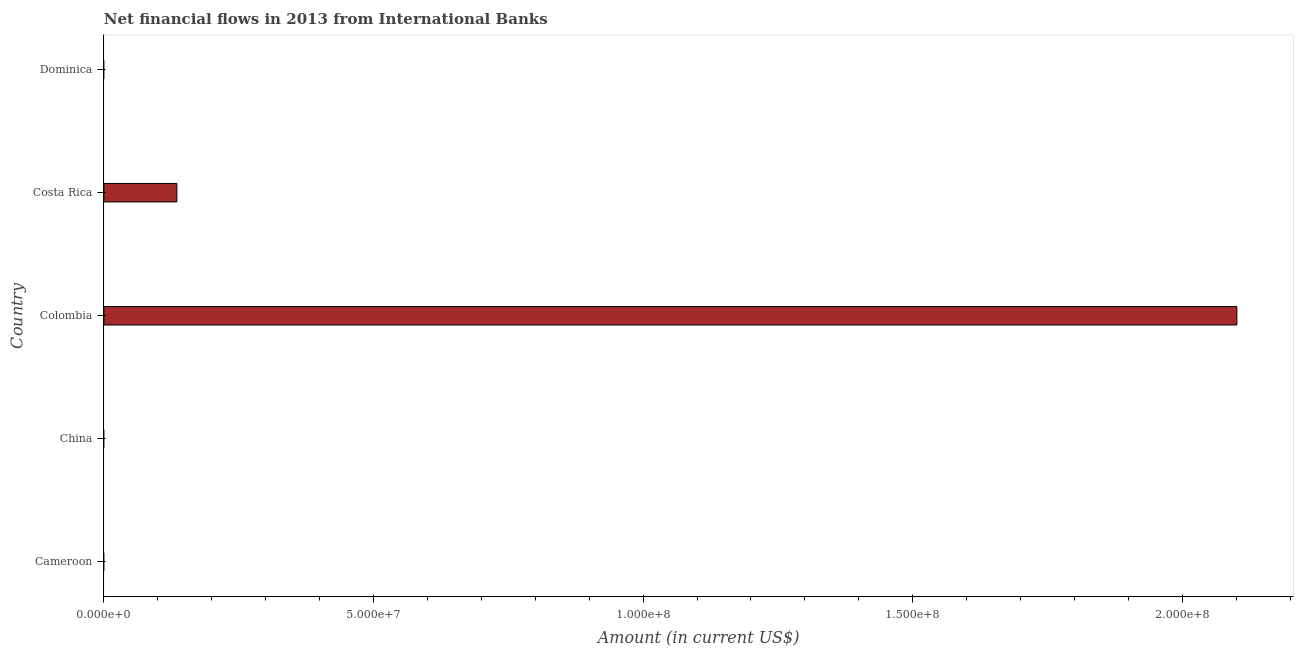Does the graph contain any zero values?
Provide a succinct answer. Yes. What is the title of the graph?
Provide a succinct answer. Net financial flows in 2013 from International Banks. What is the label or title of the X-axis?
Provide a succinct answer. Amount (in current US$). What is the label or title of the Y-axis?
Your response must be concise. Country. Across all countries, what is the maximum net financial flows from ibrd?
Provide a succinct answer. 2.10e+08. What is the sum of the net financial flows from ibrd?
Offer a very short reply. 2.24e+08. What is the difference between the net financial flows from ibrd in Colombia and Costa Rica?
Ensure brevity in your answer.  1.97e+08. What is the average net financial flows from ibrd per country?
Ensure brevity in your answer.  4.47e+07. What is the ratio of the net financial flows from ibrd in Colombia to that in Costa Rica?
Ensure brevity in your answer.  15.52. What is the difference between the highest and the lowest net financial flows from ibrd?
Keep it short and to the point. 2.10e+08. In how many countries, is the net financial flows from ibrd greater than the average net financial flows from ibrd taken over all countries?
Provide a short and direct response. 1. What is the difference between two consecutive major ticks on the X-axis?
Keep it short and to the point. 5.00e+07. Are the values on the major ticks of X-axis written in scientific E-notation?
Your answer should be very brief. Yes. What is the Amount (in current US$) of Colombia?
Give a very brief answer. 2.10e+08. What is the Amount (in current US$) of Costa Rica?
Provide a succinct answer. 1.35e+07. What is the difference between the Amount (in current US$) in Colombia and Costa Rica?
Ensure brevity in your answer.  1.97e+08. What is the ratio of the Amount (in current US$) in Colombia to that in Costa Rica?
Your answer should be very brief. 15.52. 